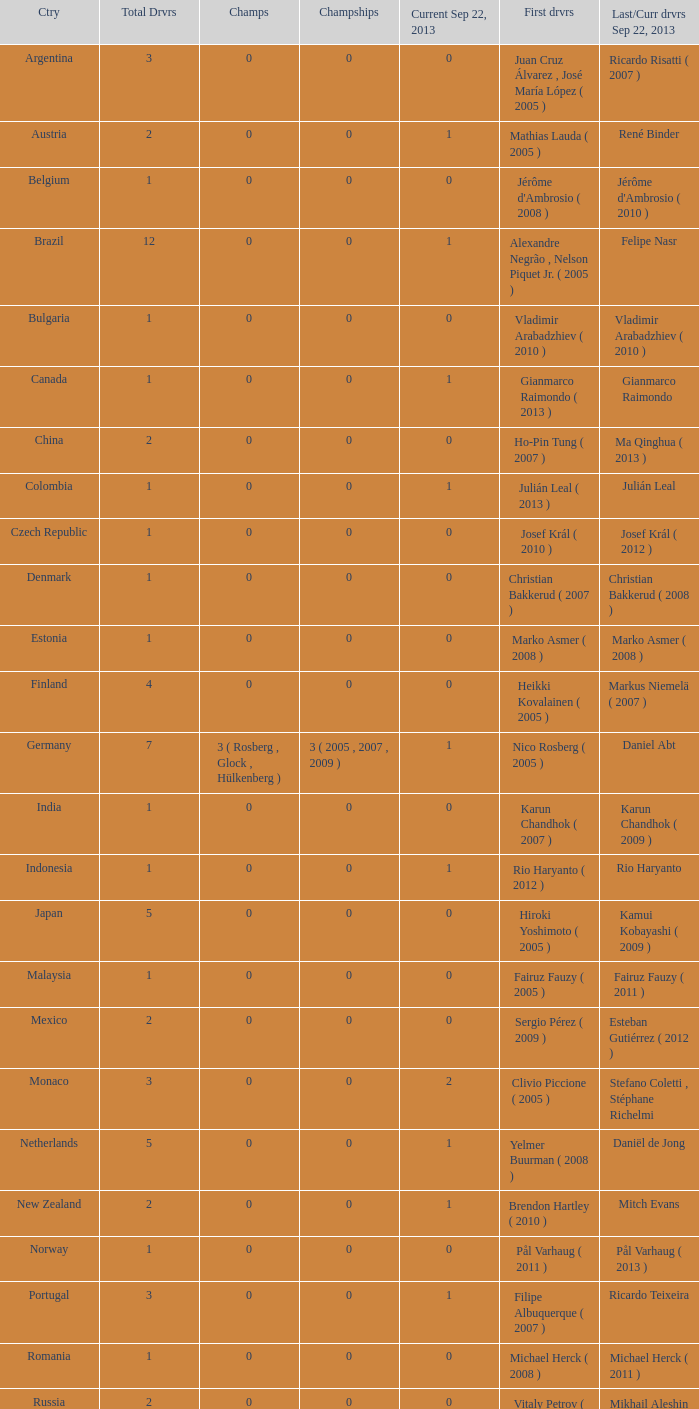How many entries are there for total drivers when the Last driver for september 22, 2013 was gianmarco raimondo? 1.0. 